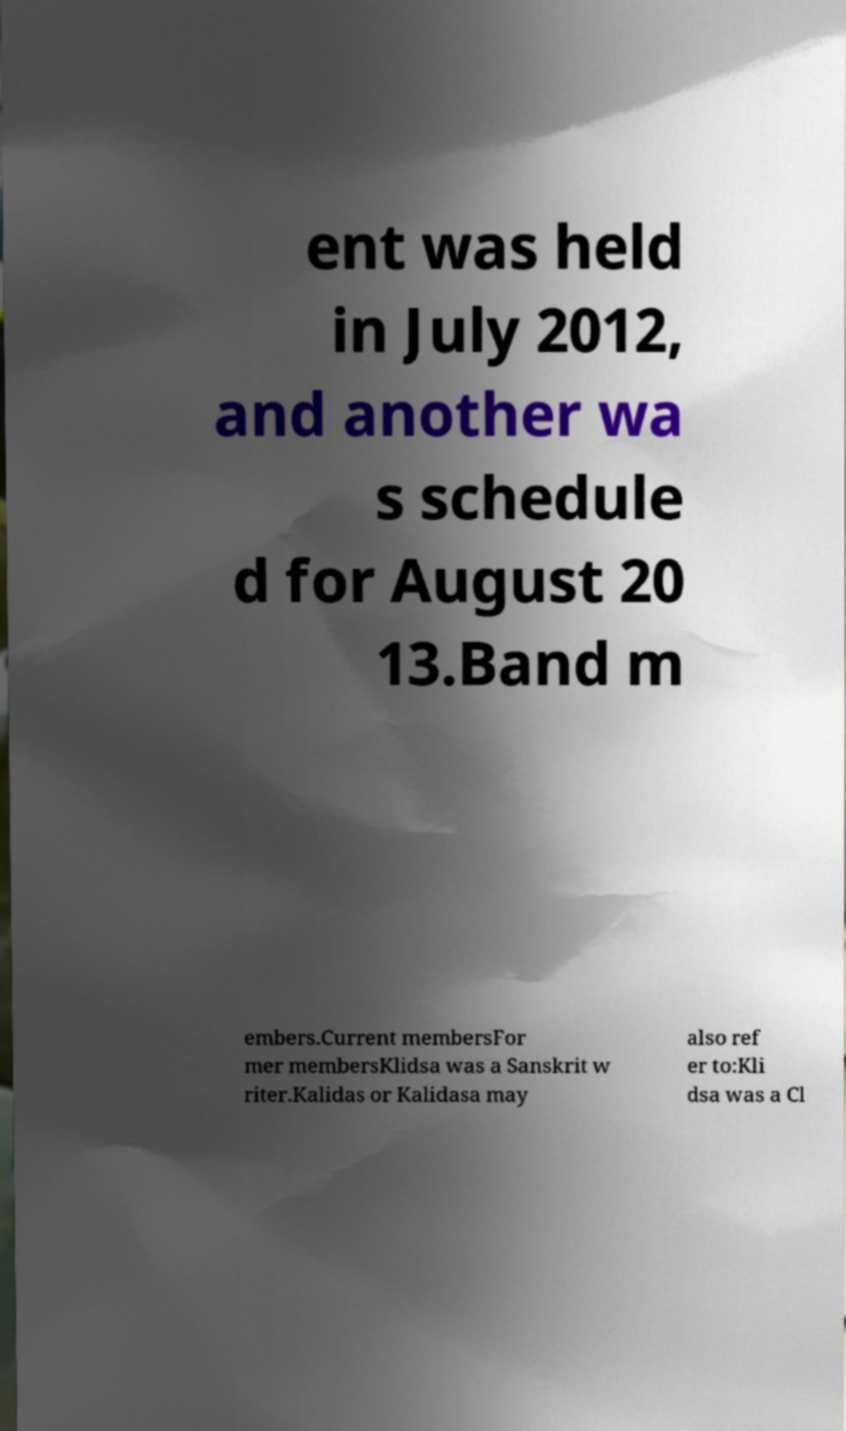Please identify and transcribe the text found in this image. ent was held in July 2012, and another wa s schedule d for August 20 13.Band m embers.Current membersFor mer membersKlidsa was a Sanskrit w riter.Kalidas or Kalidasa may also ref er to:Kli dsa was a Cl 